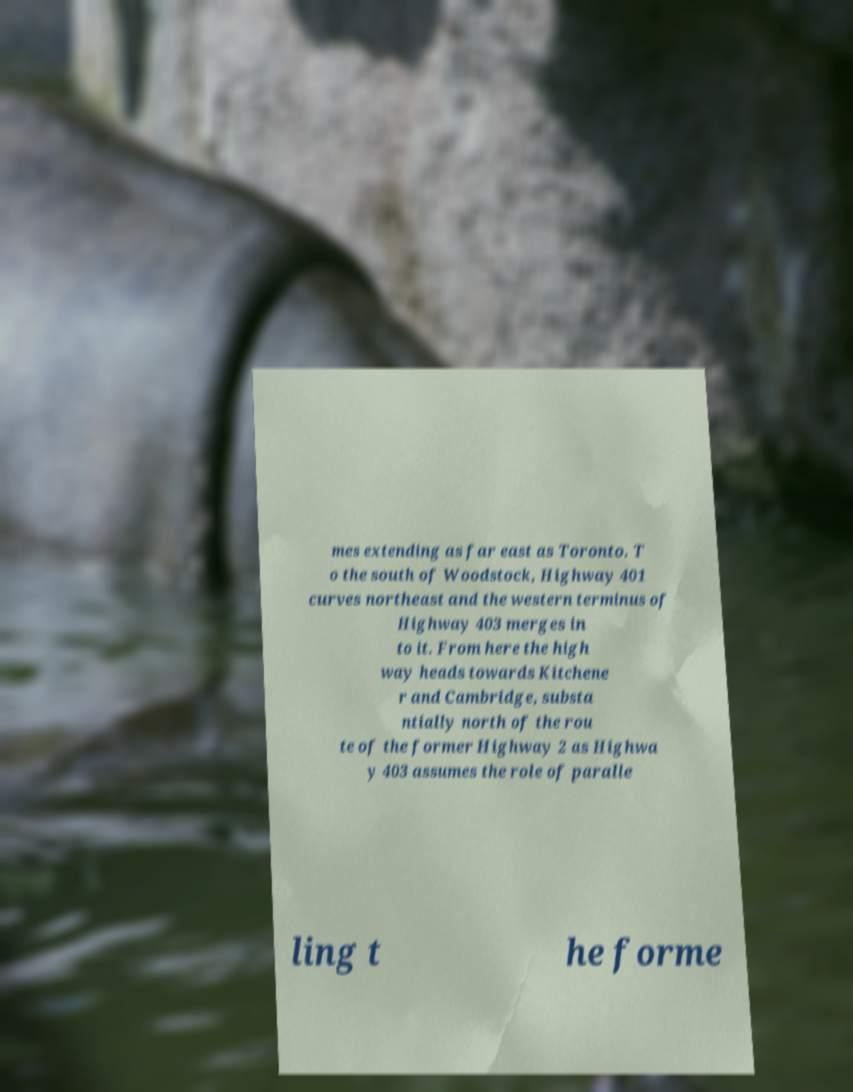Can you accurately transcribe the text from the provided image for me? mes extending as far east as Toronto. T o the south of Woodstock, Highway 401 curves northeast and the western terminus of Highway 403 merges in to it. From here the high way heads towards Kitchene r and Cambridge, substa ntially north of the rou te of the former Highway 2 as Highwa y 403 assumes the role of paralle ling t he forme 